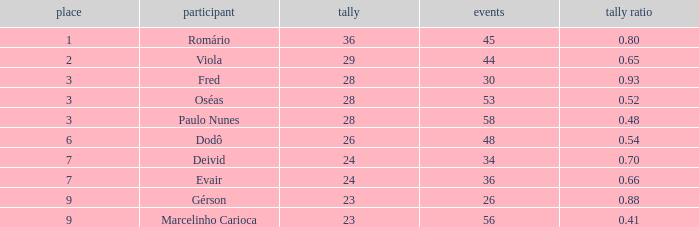How many goal ratios have rank of 2 with more than 44 games? 0.0. 